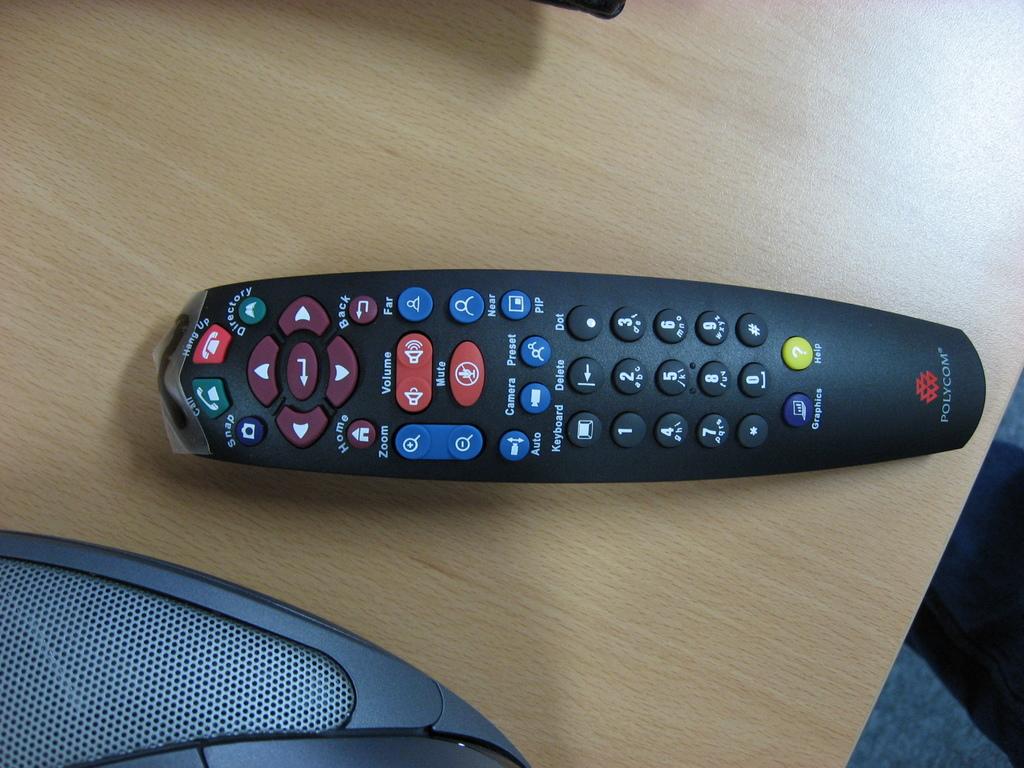What symbol is on the yellow button?
Your answer should be compact. ?. 